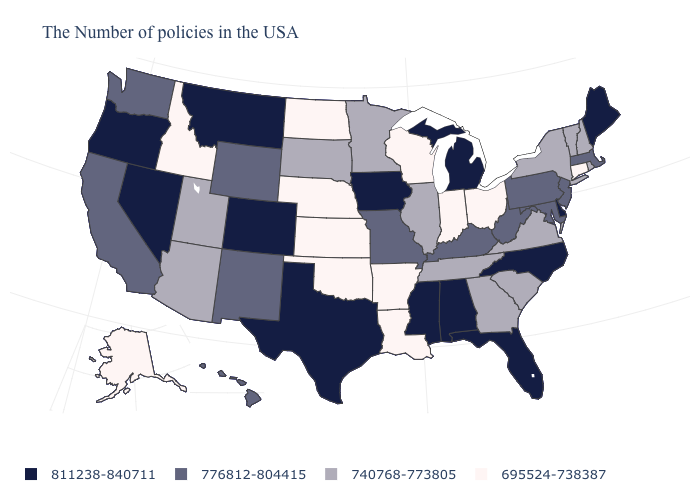Name the states that have a value in the range 695524-738387?
Write a very short answer. Connecticut, Ohio, Indiana, Wisconsin, Louisiana, Arkansas, Kansas, Nebraska, Oklahoma, North Dakota, Idaho, Alaska. What is the value of Virginia?
Give a very brief answer. 740768-773805. Name the states that have a value in the range 811238-840711?
Concise answer only. Maine, Delaware, North Carolina, Florida, Michigan, Alabama, Mississippi, Iowa, Texas, Colorado, Montana, Nevada, Oregon. What is the value of Rhode Island?
Answer briefly. 740768-773805. Among the states that border Oregon , does Nevada have the highest value?
Quick response, please. Yes. Which states have the highest value in the USA?
Short answer required. Maine, Delaware, North Carolina, Florida, Michigan, Alabama, Mississippi, Iowa, Texas, Colorado, Montana, Nevada, Oregon. Does Tennessee have the same value as Virginia?
Short answer required. Yes. Does Colorado have a higher value than Nebraska?
Concise answer only. Yes. Name the states that have a value in the range 776812-804415?
Write a very short answer. Massachusetts, New Jersey, Maryland, Pennsylvania, West Virginia, Kentucky, Missouri, Wyoming, New Mexico, California, Washington, Hawaii. What is the value of Montana?
Short answer required. 811238-840711. What is the value of West Virginia?
Give a very brief answer. 776812-804415. Among the states that border Kentucky , which have the lowest value?
Write a very short answer. Ohio, Indiana. What is the highest value in the South ?
Give a very brief answer. 811238-840711. Does Michigan have a lower value than South Carolina?
Keep it brief. No. What is the lowest value in the MidWest?
Give a very brief answer. 695524-738387. 